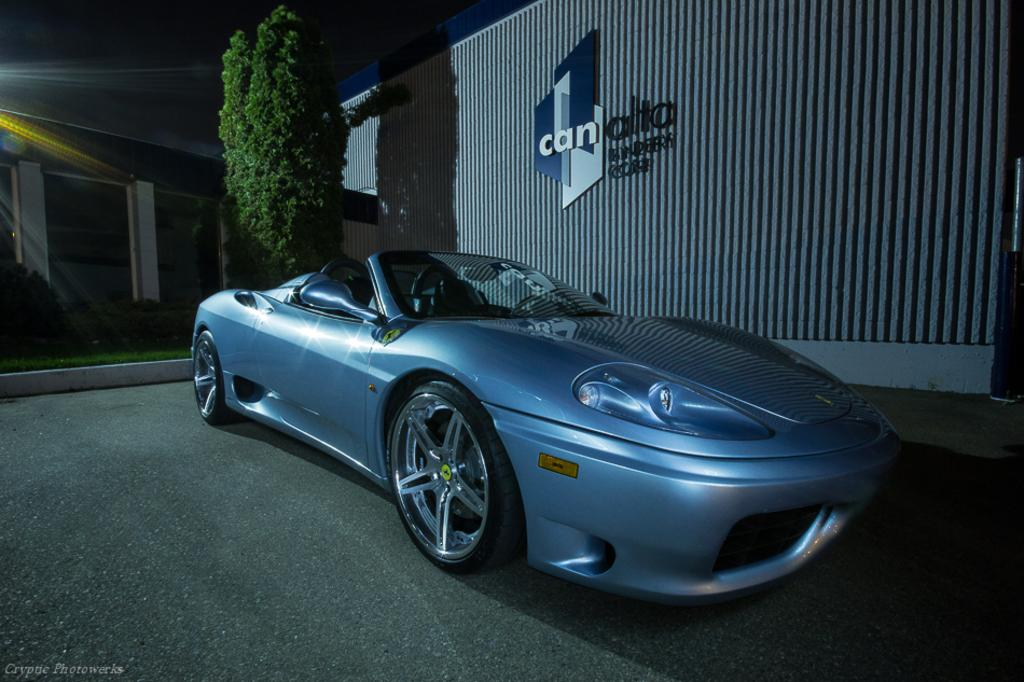What is the main subject of the image? The main subject of the image is a car on the road. What can be seen in the background of the image? There is a building, grass, a tree, and a wall with text in the background of the image. What is visible at the top of the image? The sky is visible at the top of the image. What type of game is being played on the wall with text in the image? There is no game being played on the wall with text in the image. The wall has text, but it is not related to any game. 